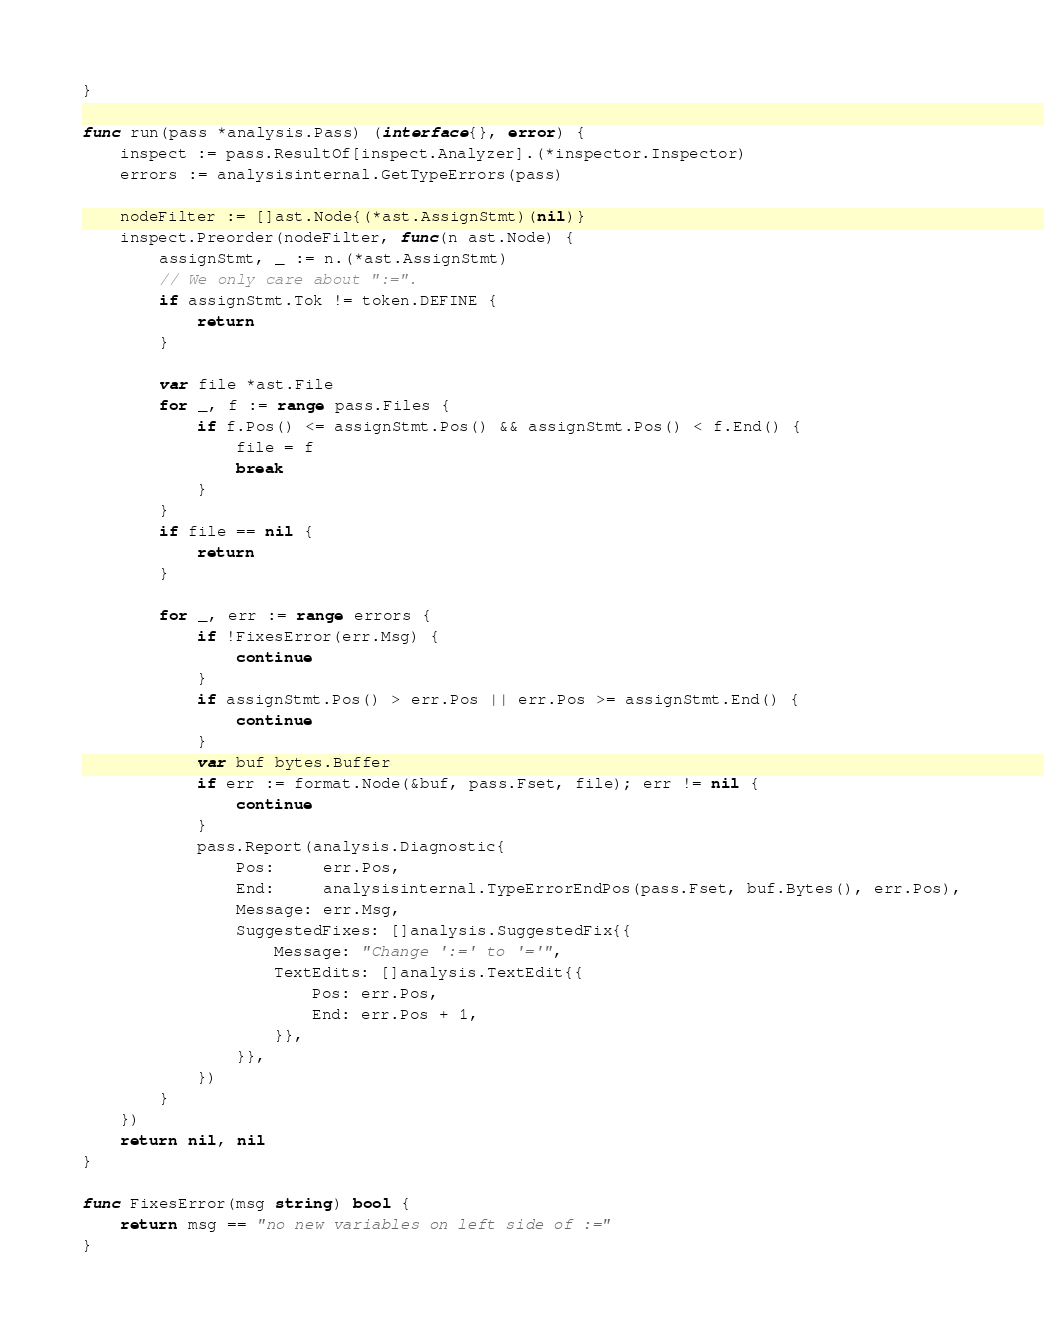Convert code to text. <code><loc_0><loc_0><loc_500><loc_500><_Go_>}

func run(pass *analysis.Pass) (interface{}, error) {
	inspect := pass.ResultOf[inspect.Analyzer].(*inspector.Inspector)
	errors := analysisinternal.GetTypeErrors(pass)

	nodeFilter := []ast.Node{(*ast.AssignStmt)(nil)}
	inspect.Preorder(nodeFilter, func(n ast.Node) {
		assignStmt, _ := n.(*ast.AssignStmt)
		// We only care about ":=".
		if assignStmt.Tok != token.DEFINE {
			return
		}

		var file *ast.File
		for _, f := range pass.Files {
			if f.Pos() <= assignStmt.Pos() && assignStmt.Pos() < f.End() {
				file = f
				break
			}
		}
		if file == nil {
			return
		}

		for _, err := range errors {
			if !FixesError(err.Msg) {
				continue
			}
			if assignStmt.Pos() > err.Pos || err.Pos >= assignStmt.End() {
				continue
			}
			var buf bytes.Buffer
			if err := format.Node(&buf, pass.Fset, file); err != nil {
				continue
			}
			pass.Report(analysis.Diagnostic{
				Pos:     err.Pos,
				End:     analysisinternal.TypeErrorEndPos(pass.Fset, buf.Bytes(), err.Pos),
				Message: err.Msg,
				SuggestedFixes: []analysis.SuggestedFix{{
					Message: "Change ':=' to '='",
					TextEdits: []analysis.TextEdit{{
						Pos: err.Pos,
						End: err.Pos + 1,
					}},
				}},
			})
		}
	})
	return nil, nil
}

func FixesError(msg string) bool {
	return msg == "no new variables on left side of :="
}
</code> 